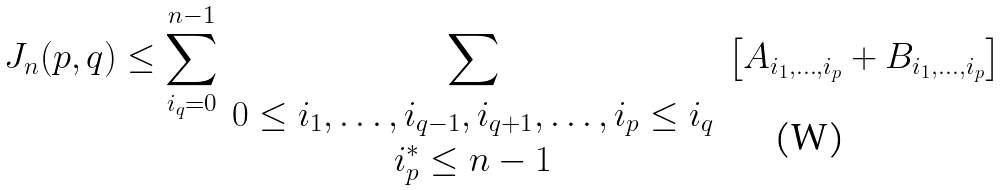<formula> <loc_0><loc_0><loc_500><loc_500>J _ { n } ( p , q ) \leq \sum _ { i _ { q } = 0 } ^ { n - 1 } \sum _ { \begin{array} { c } 0 \leq i _ { 1 } , \dots , i _ { q - 1 } , i _ { q + 1 } , \dots , i _ { p } \leq i _ { q } \\ i _ { p } ^ { * } \leq n - 1 \end{array} } \left [ A _ { i _ { 1 } , \dots , i _ { p } } + B _ { i _ { 1 } , \dots , i _ { p } } \right ]</formula> 